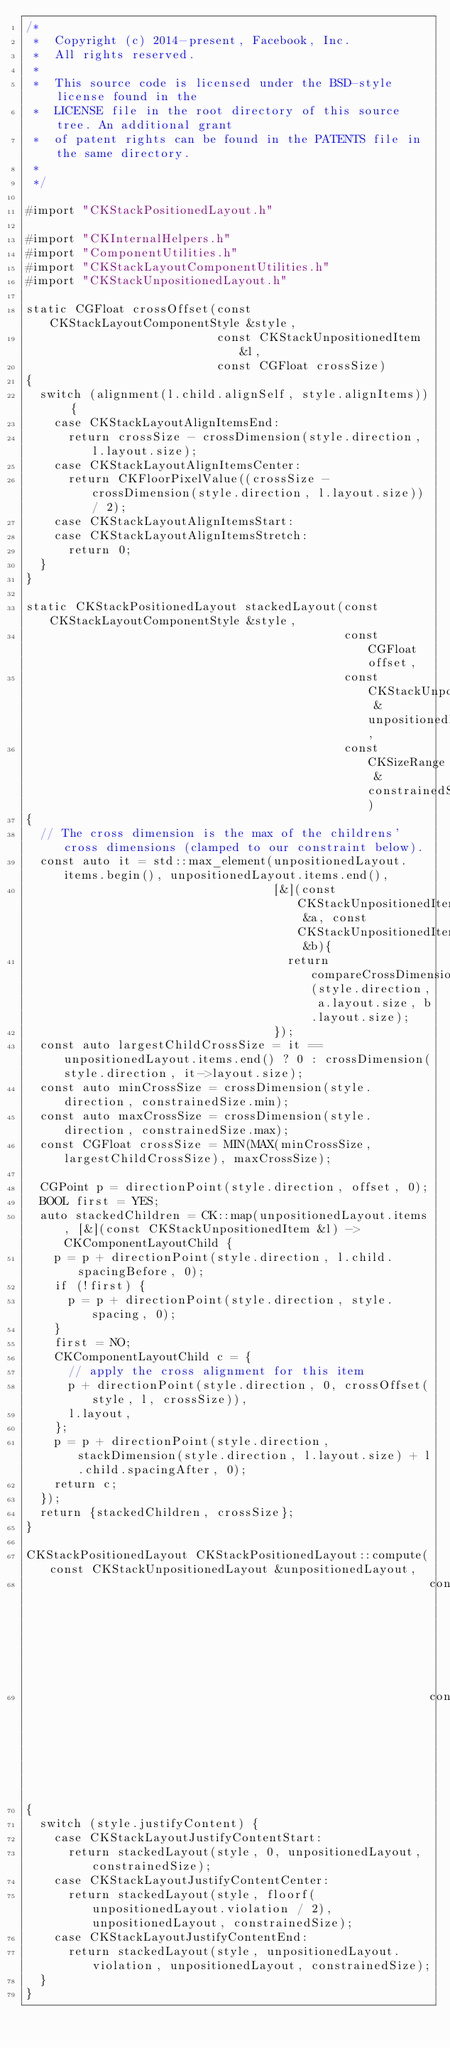<code> <loc_0><loc_0><loc_500><loc_500><_ObjectiveC_>/*
 *  Copyright (c) 2014-present, Facebook, Inc.
 *  All rights reserved.
 *
 *  This source code is licensed under the BSD-style license found in the
 *  LICENSE file in the root directory of this source tree. An additional grant
 *  of patent rights can be found in the PATENTS file in the same directory.
 *
 */

#import "CKStackPositionedLayout.h"

#import "CKInternalHelpers.h"
#import "ComponentUtilities.h"
#import "CKStackLayoutComponentUtilities.h"
#import "CKStackUnpositionedLayout.h"

static CGFloat crossOffset(const CKStackLayoutComponentStyle &style,
                           const CKStackUnpositionedItem &l,
                           const CGFloat crossSize)
{
  switch (alignment(l.child.alignSelf, style.alignItems)) {
    case CKStackLayoutAlignItemsEnd:
      return crossSize - crossDimension(style.direction, l.layout.size);
    case CKStackLayoutAlignItemsCenter:
      return CKFloorPixelValue((crossSize - crossDimension(style.direction, l.layout.size)) / 2);
    case CKStackLayoutAlignItemsStart:
    case CKStackLayoutAlignItemsStretch:
      return 0;
  }
}

static CKStackPositionedLayout stackedLayout(const CKStackLayoutComponentStyle &style,
                                             const CGFloat offset,
                                             const CKStackUnpositionedLayout &unpositionedLayout,
                                             const CKSizeRange &constrainedSize)
{
  // The cross dimension is the max of the childrens' cross dimensions (clamped to our constraint below).
  const auto it = std::max_element(unpositionedLayout.items.begin(), unpositionedLayout.items.end(),
                                   [&](const CKStackUnpositionedItem &a, const CKStackUnpositionedItem &b){
                                     return compareCrossDimension(style.direction, a.layout.size, b.layout.size);
                                   });
  const auto largestChildCrossSize = it == unpositionedLayout.items.end() ? 0 : crossDimension(style.direction, it->layout.size);
  const auto minCrossSize = crossDimension(style.direction, constrainedSize.min);
  const auto maxCrossSize = crossDimension(style.direction, constrainedSize.max);
  const CGFloat crossSize = MIN(MAX(minCrossSize, largestChildCrossSize), maxCrossSize);

  CGPoint p = directionPoint(style.direction, offset, 0);
  BOOL first = YES;
  auto stackedChildren = CK::map(unpositionedLayout.items, [&](const CKStackUnpositionedItem &l) -> CKComponentLayoutChild {
    p = p + directionPoint(style.direction, l.child.spacingBefore, 0);
    if (!first) {
      p = p + directionPoint(style.direction, style.spacing, 0);
    }
    first = NO;
    CKComponentLayoutChild c = {
      // apply the cross alignment for this item
      p + directionPoint(style.direction, 0, crossOffset(style, l, crossSize)),
      l.layout,
    };
    p = p + directionPoint(style.direction, stackDimension(style.direction, l.layout.size) + l.child.spacingAfter, 0);
    return c;
  });
  return {stackedChildren, crossSize};
}

CKStackPositionedLayout CKStackPositionedLayout::compute(const CKStackUnpositionedLayout &unpositionedLayout,
                                                         const CKStackLayoutComponentStyle &style,
                                                         const CKSizeRange &constrainedSize)
{
  switch (style.justifyContent) {
    case CKStackLayoutJustifyContentStart:
      return stackedLayout(style, 0, unpositionedLayout, constrainedSize);
    case CKStackLayoutJustifyContentCenter:
      return stackedLayout(style, floorf(unpositionedLayout.violation / 2), unpositionedLayout, constrainedSize);
    case CKStackLayoutJustifyContentEnd:
      return stackedLayout(style, unpositionedLayout.violation, unpositionedLayout, constrainedSize);
  }
}
</code> 